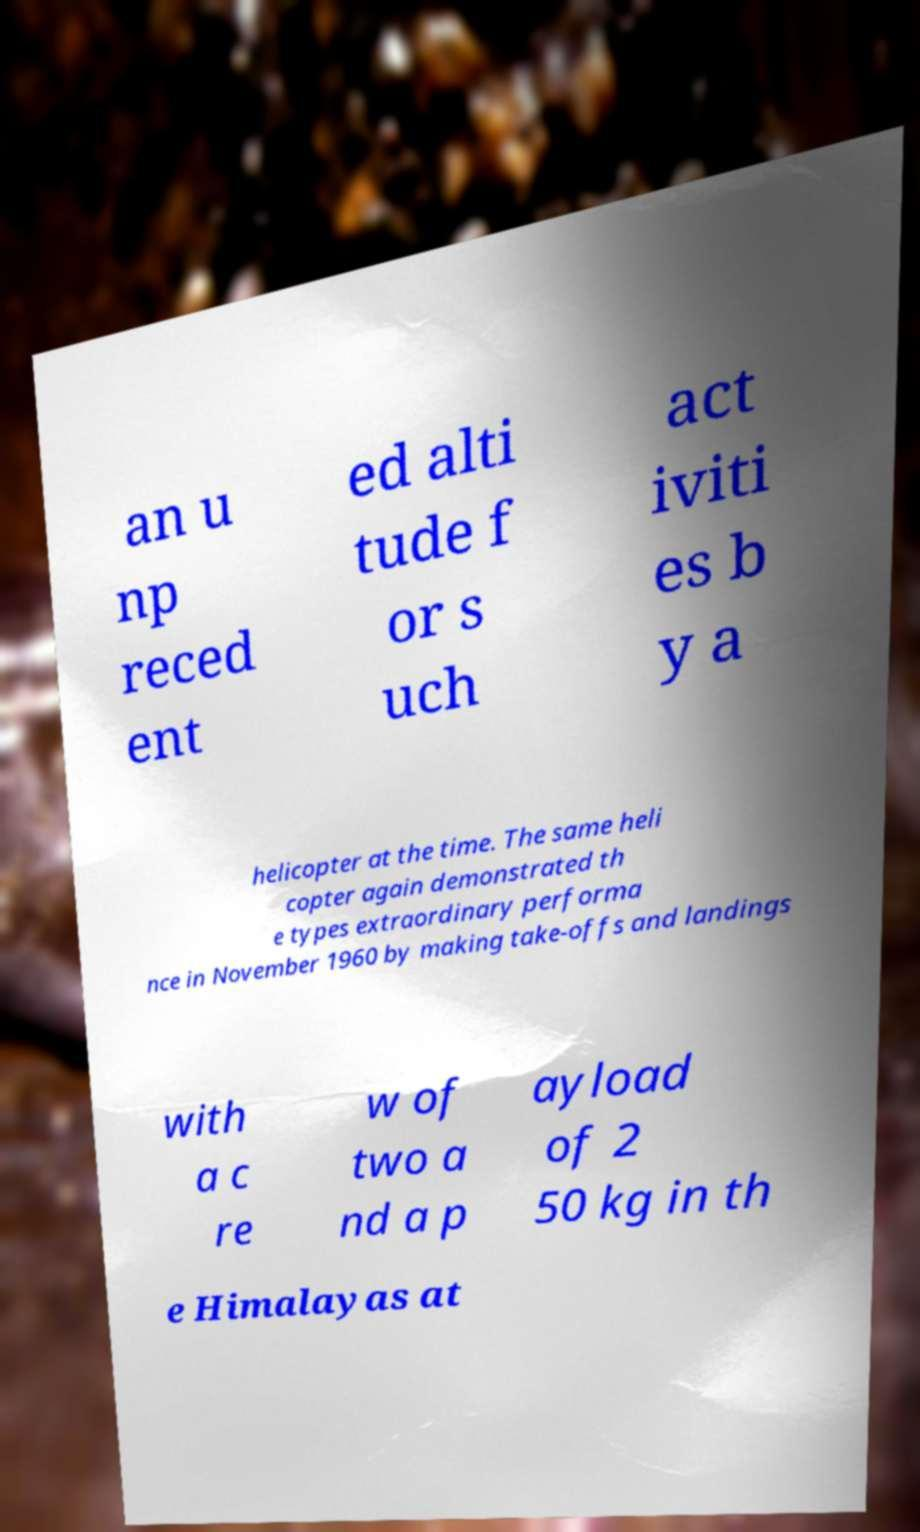For documentation purposes, I need the text within this image transcribed. Could you provide that? an u np reced ent ed alti tude f or s uch act iviti es b y a helicopter at the time. The same heli copter again demonstrated th e types extraordinary performa nce in November 1960 by making take-offs and landings with a c re w of two a nd a p ayload of 2 50 kg in th e Himalayas at 